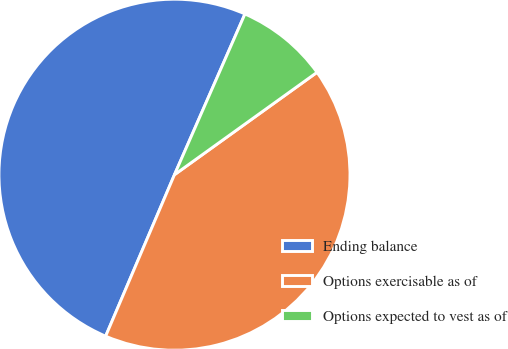Convert chart. <chart><loc_0><loc_0><loc_500><loc_500><pie_chart><fcel>Ending balance<fcel>Options exercisable as of<fcel>Options expected to vest as of<nl><fcel>50.17%<fcel>41.33%<fcel>8.51%<nl></chart> 